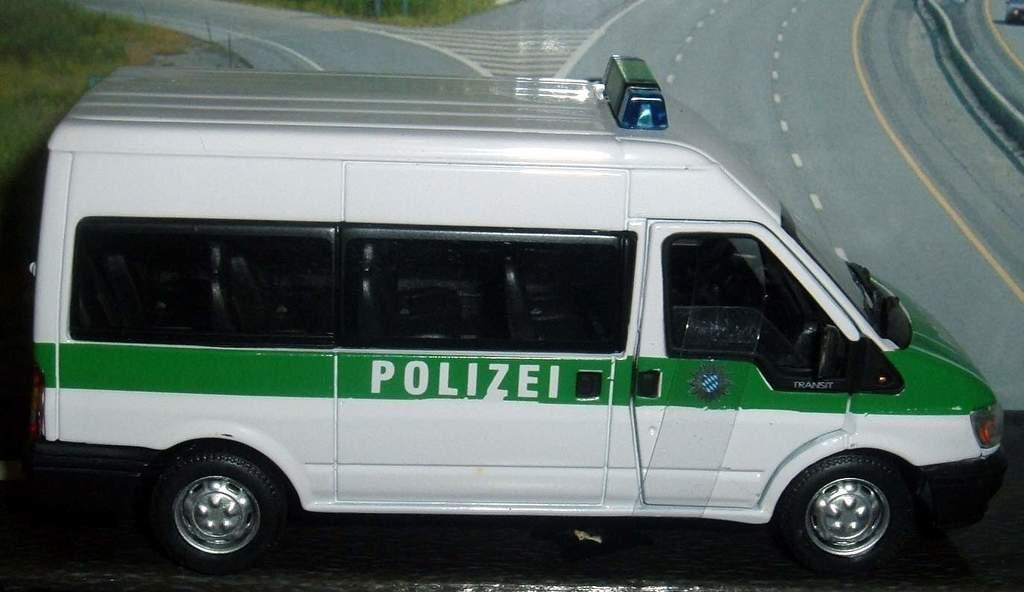Provide a one-sentence caption for the provided image. A white van with a green stripe on it that says Polizei. 